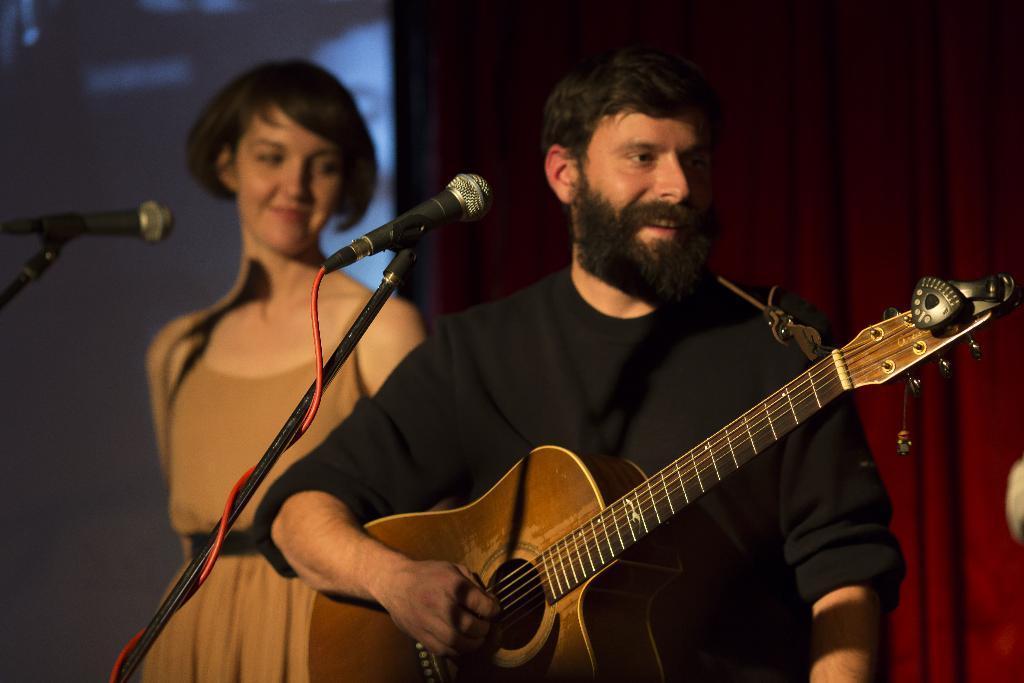How would you summarize this image in a sentence or two? There is a man playing guitar in front of microphone and girl beside him. 